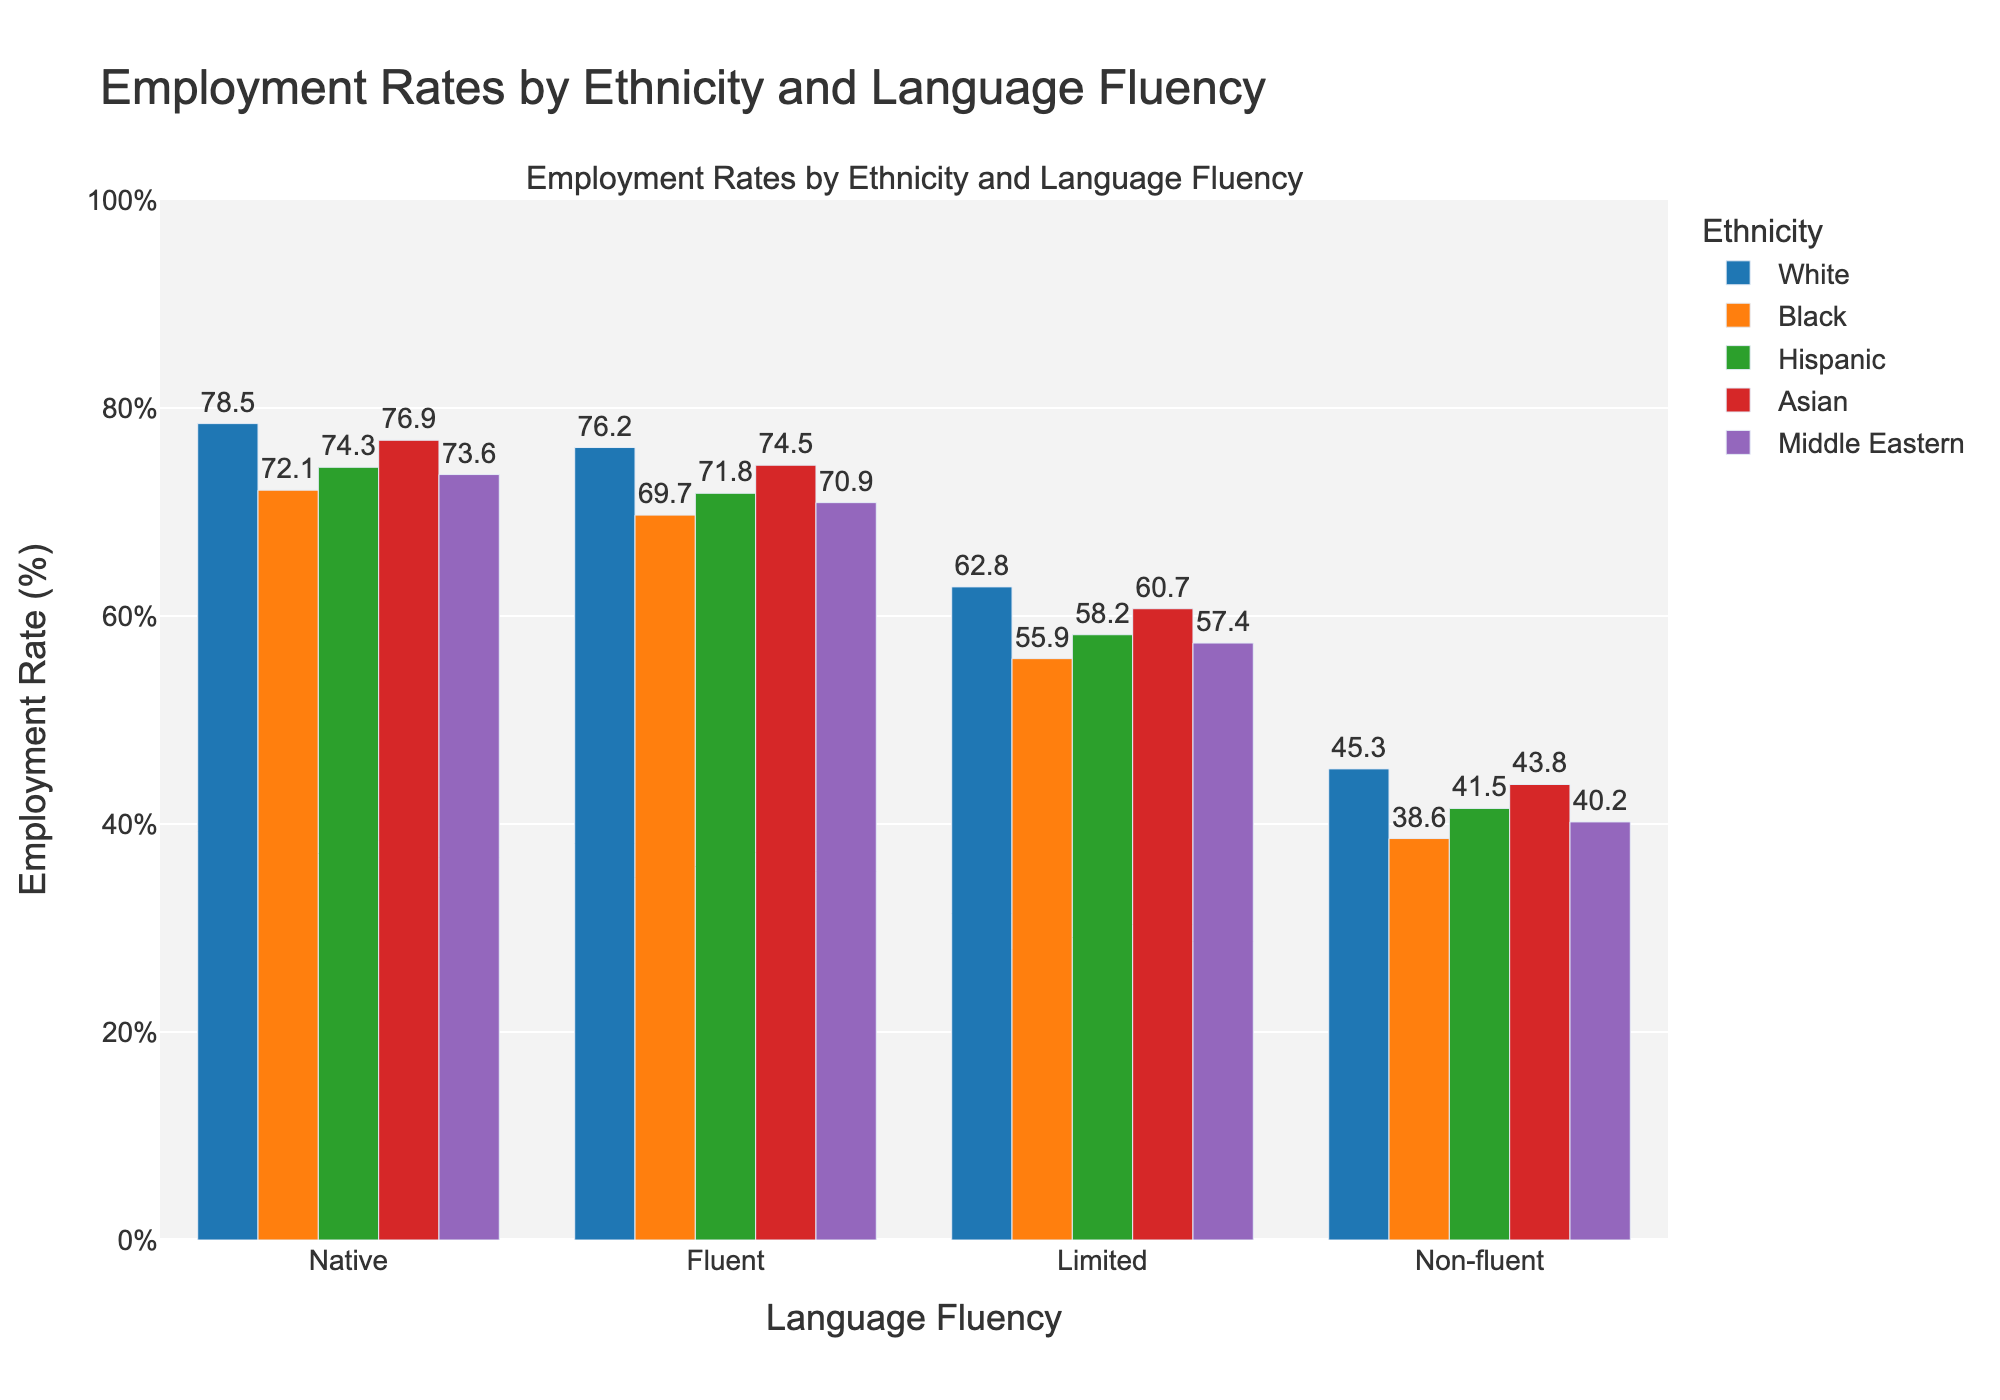What is the employment rate for Hispanic individuals who are non-fluent in the official language? Identify the bar for Hispanic individuals with non-fluent language fluency. The text value above the bar indicates the employment rate.
Answer: 41.5% Which ethnic group has the highest employment rate for those with native language fluency? Compare the heights of the bars for native fluency across all ethnicities. The highest bar represents the highest employment rate.
Answer: White How much higher is the employment rate for Asian individuals with native language fluency compared to Asian individuals with limited language fluency? Find the employment rates for Asian individuals with native fluency and limited fluency, then calculate the difference by subtracting the limited fluency rate from the native fluency rate. Native: 76.9, Limited: 60.7, Difference: 76.9 - 60.7.
Answer: 16.2% What is the average employment rate for Black individuals across all levels of language fluency? Sum the employment rates for Black individuals across all levels of fluency (Native, Fluent, Limited, Non-fluent) and divide by the number of rates: (72.1 + 69.7 + 55.9 + 38.6) / 4.
Answer: 59.075% Which two ethnic groups have the closest employment rates for individuals with limited language fluency? Compare the bars for limited language fluency across all ethnic groups and find the two closest values. Black: 55.9 and Middle Eastern: 57.4.
Answer: Black and Middle Eastern Do any ethnic groups have employment rates below 50% at any fluency level? Check the bars for each fluency level across all ethnicities to see if any fall below 50%. Black (Non-fluent: 38.6), Hispanic (Non-fluent: 41.5), Asian (Non-fluent: 43.8), Middle Eastern (Non-fluent: 40.2), White (Non-fluent: 45.3).
Answer: Yes How does the employment rate for White individuals with fluent language compare to that of Hispanic individuals with the same fluency level? Compare the heights of the bars for White and Hispanic individuals with fluent language.
Answer: White: Higher Which fluency level shows the greatest drop in employment rates across all ethnic groups? Compare the relative drops in employment rates from one fluency level to the next across all ethnic groups. The greatest drop is seen in non-fluent across all ethnic groups.
Answer: Non-fluent Calculate the difference in employment rates between the highest and lowest ethnic groups for fluent language proficiency. Identify the highest and lowest bars for fluent language proficiency and subtract the lower rate from the higher rate. Highest: White (76.2), Lowest: Black (69.7), Difference: 76.2 - 69.7.
Answer: 6.5% What visual pattern can be observed regarding the relationship between language fluency and employment rates for all ethnic groups? Observe the general trend across all bars grouped by fluency level for each ethnicity. Employment rates decrease progressively from native to non-fluent across all ethnicities.
Answer: Decrease in rates with lower fluency 